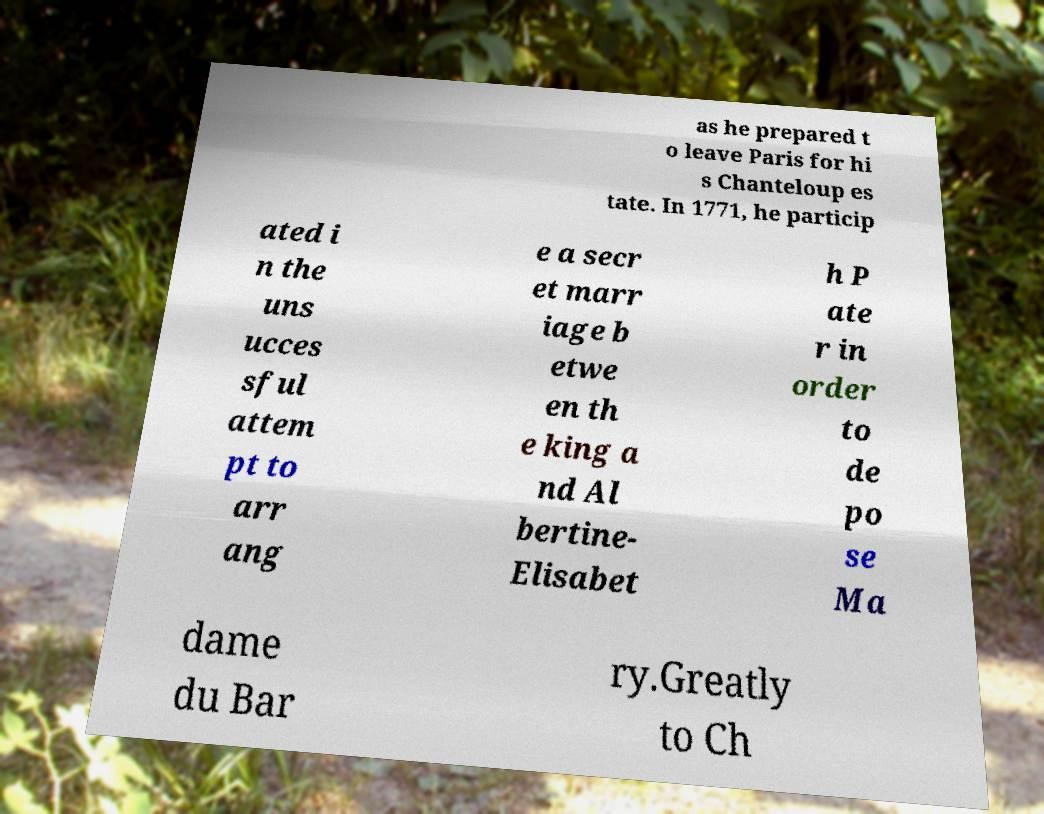Could you extract and type out the text from this image? as he prepared t o leave Paris for hi s Chanteloup es tate. In 1771, he particip ated i n the uns ucces sful attem pt to arr ang e a secr et marr iage b etwe en th e king a nd Al bertine- Elisabet h P ate r in order to de po se Ma dame du Bar ry.Greatly to Ch 